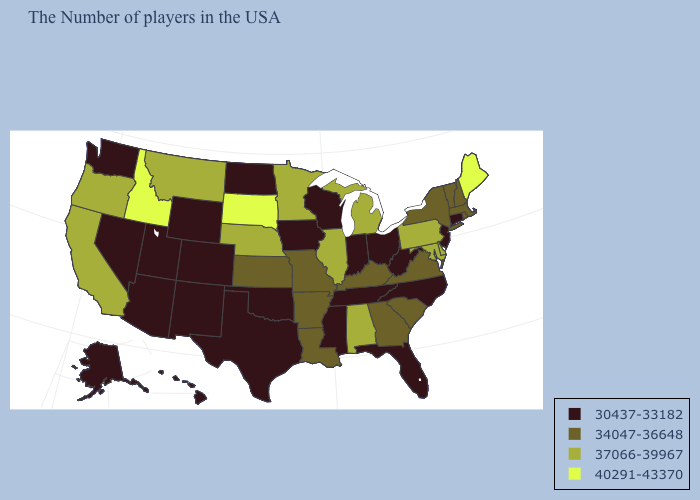What is the value of Maryland?
Be succinct. 37066-39967. What is the value of Pennsylvania?
Quick response, please. 37066-39967. Name the states that have a value in the range 37066-39967?
Concise answer only. Delaware, Maryland, Pennsylvania, Michigan, Alabama, Illinois, Minnesota, Nebraska, Montana, California, Oregon. What is the highest value in the West ?
Give a very brief answer. 40291-43370. Among the states that border New Hampshire , does Massachusetts have the highest value?
Answer briefly. No. Name the states that have a value in the range 40291-43370?
Write a very short answer. Maine, South Dakota, Idaho. Is the legend a continuous bar?
Keep it brief. No. Does Hawaii have the highest value in the USA?
Concise answer only. No. Does Michigan have the same value as Connecticut?
Give a very brief answer. No. Among the states that border Montana , which have the highest value?
Quick response, please. South Dakota, Idaho. What is the value of Louisiana?
Concise answer only. 34047-36648. What is the value of South Carolina?
Keep it brief. 34047-36648. Does Massachusetts have the highest value in the Northeast?
Keep it brief. No. Which states have the lowest value in the Northeast?
Write a very short answer. Connecticut, New Jersey. Name the states that have a value in the range 34047-36648?
Be succinct. Massachusetts, Rhode Island, New Hampshire, Vermont, New York, Virginia, South Carolina, Georgia, Kentucky, Louisiana, Missouri, Arkansas, Kansas. 